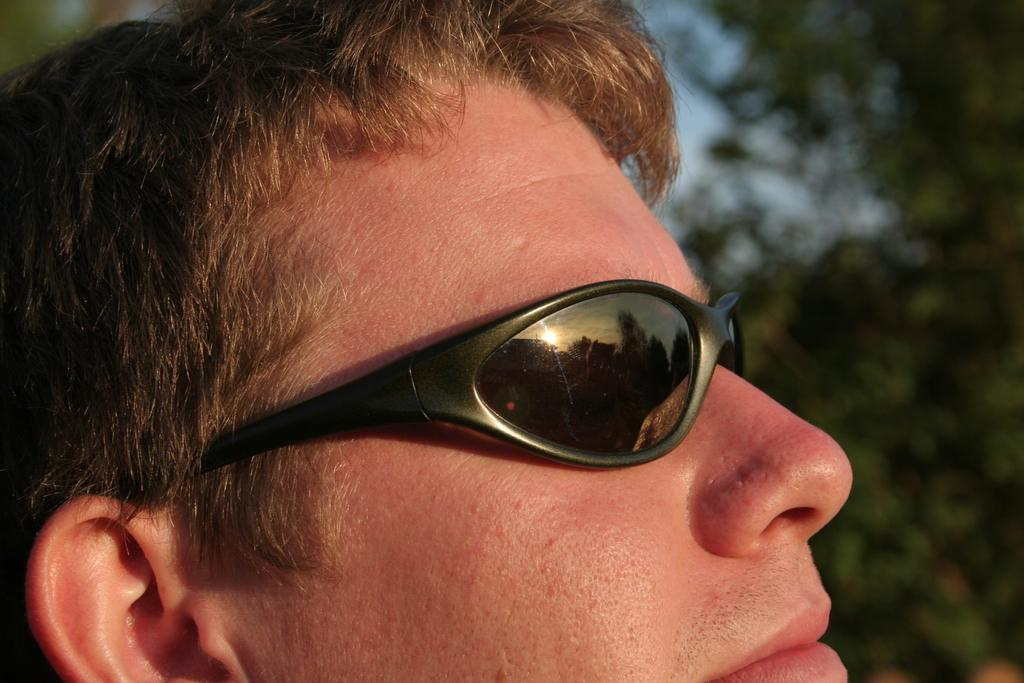Who is present in the image? There is a man in the picture. What is the man wearing in the image? The man is wearing sunglasses. What can be seen on the right side of the image? There are trees on the right side of the image. What type of beast can be seen interacting with the man in the image? There is no beast present in the image; only the man and trees are visible. What color is the chalk used to draw on the trees in the image? There is no chalk or drawing present in the image; only the man, sunglasses, and trees are visible. 